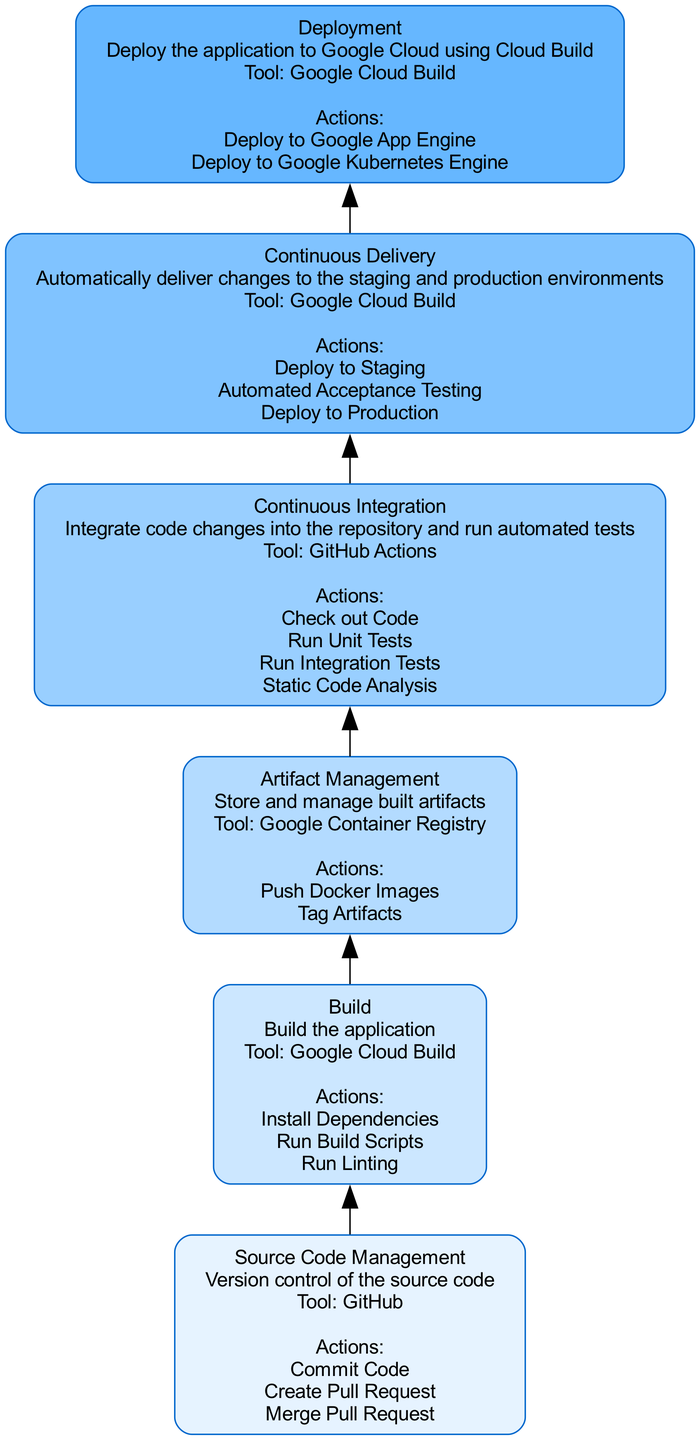What is the topmost stage in the CI/CD pipeline? The topmost stage in the diagram is "Deployment". The diagram flows from bottom to top, and the highest node represents the last step in the process.
Answer: Deployment How many actions are listed under the "Build" stage? The "Build" stage includes three actions: "Install Dependencies", "Run Build Scripts", and "Run Linting". Counting these actions gives us a total of three.
Answer: 3 Which tool is used for Continuous Integration? According to the diagram, "GitHub Actions" is used for Continuous Integration. Each stage lists the tools utilized, and this is specifically mentioned under the Continuous Integration stage.
Answer: GitHub Actions What is the relationship between "Continuous Integration" and "Continuous Delivery"? The diagram shows an upward flow from "Continuous Integration" to "Continuous Delivery", indicating that the output of Continuous Integration is input for Continuous Delivery. This relationship signifies that after integration, the next step is delivery.
Answer: Upward flow How many total stages are represented in the CI/CD pipeline? By counting each stage listed in the diagram—Source Code Management, Build, Artifact Management, Continuous Integration, Continuous Delivery, and Deployment—we find a total of six stages.
Answer: 6 What action is the last step in the "Continuous Delivery" stage? The last action listed under the "Continuous Delivery" stage is "Deploy to Production". The actions are presented in a sequential order, with this being the final action specified in that section.
Answer: Deploy to Production What color scheme is used in the diagram for the stages? The nodes in the diagram employ a gradient color palette progressing from light blue to darker shades, specifically using six different shades of blue. Each stage is filled with a different color from this palette.
Answer: Shades of blue Which stage precedes "Artifact Management"? The stage that comes right before "Artifact Management" in the diagram is "Build". By following the upward flow, we can determine the sequence and identify the immediately preceding stage.
Answer: Build What tool is mentioned for managing artifacts? The tool noted for managing artifacts in the diagram is "Google Container Registry". It is specifically highlighted within the Artifact Management stage as the tool used for that purpose.
Answer: Google Container Registry 